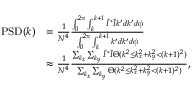Convert formula to latex. <formula><loc_0><loc_0><loc_500><loc_500>\begin{array} { r l } { P S D ( k ) } & { = \frac { 1 } { N ^ { 4 } } \frac { \int _ { 0 } ^ { 2 \pi } \int _ { k } ^ { k + 1 } \tilde { I } ^ { * } \tilde { I } k ^ { \prime } d k ^ { \prime } d \phi } { \int _ { 0 } ^ { 2 \pi } \int _ { k } ^ { k + 1 } k ^ { \prime } d k ^ { \prime } d \phi } } \\ & { \approx \frac { 1 } { N ^ { 4 } } \frac { \sum _ { k _ { x } } \sum _ { k _ { y } } \tilde { I } ^ { * } \tilde { I } \Theta ( k ^ { 2 } \leq k _ { x } ^ { 2 } + k _ { y } ^ { 2 } < ( k + 1 ) ^ { 2 } ) } { \sum _ { k _ { x } } \sum _ { k _ { y } } \Theta ( k ^ { 2 } \leq k _ { x } ^ { 2 } + k _ { y } ^ { 2 } < ( k + 1 ) ^ { 2 } ) } , } \end{array}</formula> 